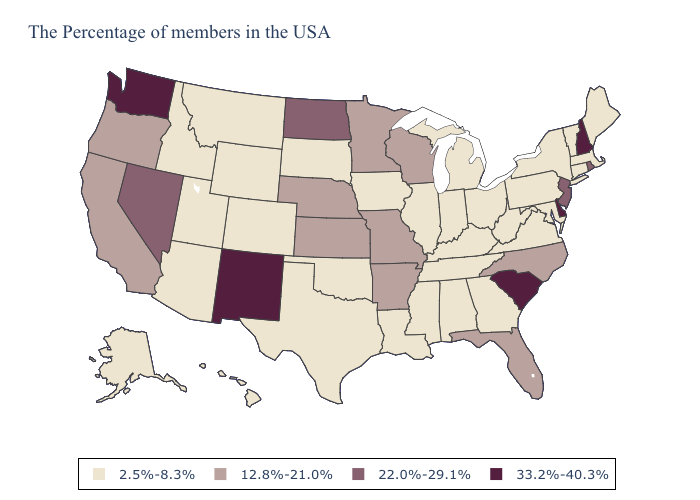Does the first symbol in the legend represent the smallest category?
Concise answer only. Yes. What is the value of Wisconsin?
Short answer required. 12.8%-21.0%. Name the states that have a value in the range 12.8%-21.0%?
Quick response, please. North Carolina, Florida, Wisconsin, Missouri, Arkansas, Minnesota, Kansas, Nebraska, California, Oregon. What is the lowest value in states that border Mississippi?
Give a very brief answer. 2.5%-8.3%. Among the states that border Texas , which have the lowest value?
Keep it brief. Louisiana, Oklahoma. Which states hav the highest value in the South?
Concise answer only. Delaware, South Carolina. Among the states that border Iowa , which have the lowest value?
Quick response, please. Illinois, South Dakota. Does Indiana have the highest value in the USA?
Short answer required. No. Does Oregon have the same value as Arkansas?
Be succinct. Yes. What is the value of Kansas?
Answer briefly. 12.8%-21.0%. Name the states that have a value in the range 22.0%-29.1%?
Short answer required. Rhode Island, New Jersey, North Dakota, Nevada. Does Virginia have a lower value than Minnesota?
Quick response, please. Yes. Which states hav the highest value in the South?
Keep it brief. Delaware, South Carolina. What is the value of Florida?
Write a very short answer. 12.8%-21.0%. 